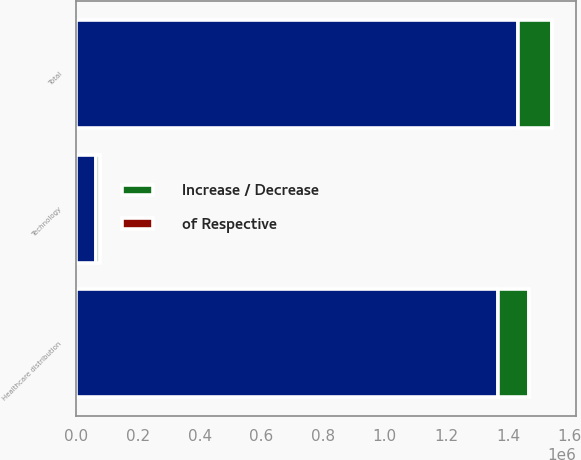<chart> <loc_0><loc_0><loc_500><loc_500><stacked_bar_chart><ecel><fcel>Healthcare distribution<fcel>Technology<fcel>Total<nl><fcel>nan<fcel>1.36811e+06<fcel>63661<fcel>1.43177e+06<nl><fcel>of Respective<fcel>22<fcel>39<fcel>22.4<nl><fcel>Increase / Decrease<fcel>100078<fcel>12538<fcel>112616<nl></chart> 